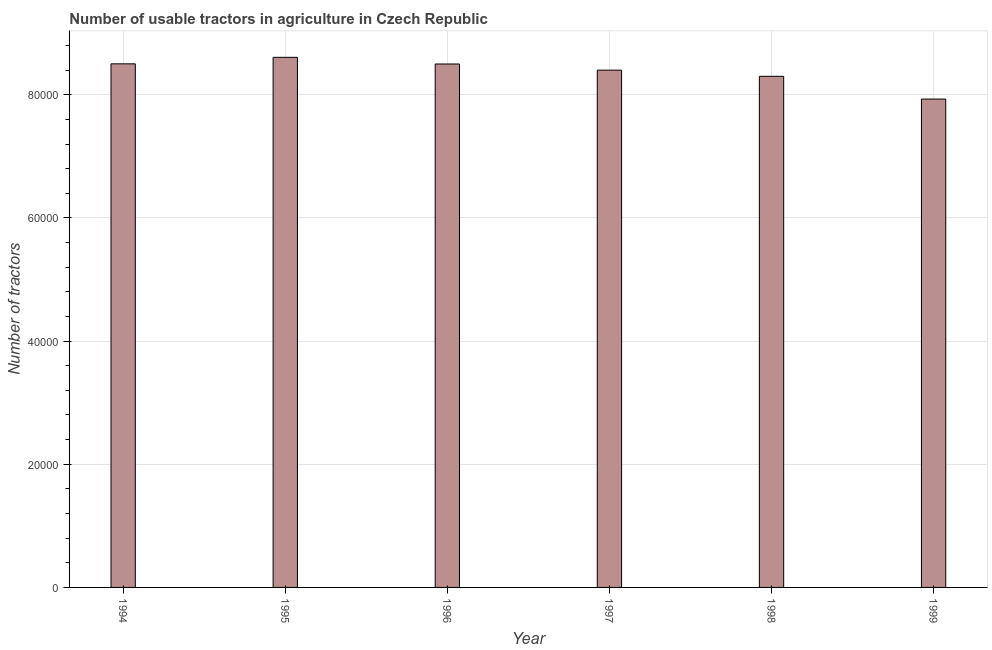Does the graph contain grids?
Keep it short and to the point. Yes. What is the title of the graph?
Offer a terse response. Number of usable tractors in agriculture in Czech Republic. What is the label or title of the Y-axis?
Your answer should be compact. Number of tractors. What is the number of tractors in 1999?
Provide a short and direct response. 7.93e+04. Across all years, what is the maximum number of tractors?
Offer a very short reply. 8.61e+04. Across all years, what is the minimum number of tractors?
Your answer should be very brief. 7.93e+04. In which year was the number of tractors minimum?
Make the answer very short. 1999. What is the sum of the number of tractors?
Your answer should be very brief. 5.02e+05. What is the difference between the number of tractors in 1994 and 1997?
Your answer should be compact. 1025. What is the average number of tractors per year?
Your answer should be compact. 8.37e+04. What is the median number of tractors?
Give a very brief answer. 8.45e+04. Do a majority of the years between 1999 and 1995 (inclusive) have number of tractors greater than 44000 ?
Give a very brief answer. Yes. What is the difference between the highest and the second highest number of tractors?
Make the answer very short. 1056. Is the sum of the number of tractors in 1995 and 1998 greater than the maximum number of tractors across all years?
Give a very brief answer. Yes. What is the difference between the highest and the lowest number of tractors?
Keep it short and to the point. 6777. Are all the bars in the graph horizontal?
Give a very brief answer. No. How many years are there in the graph?
Ensure brevity in your answer.  6. What is the difference between two consecutive major ticks on the Y-axis?
Make the answer very short. 2.00e+04. Are the values on the major ticks of Y-axis written in scientific E-notation?
Offer a very short reply. No. What is the Number of tractors of 1994?
Your answer should be compact. 8.50e+04. What is the Number of tractors in 1995?
Ensure brevity in your answer.  8.61e+04. What is the Number of tractors in 1996?
Your answer should be compact. 8.50e+04. What is the Number of tractors in 1997?
Make the answer very short. 8.40e+04. What is the Number of tractors in 1998?
Your response must be concise. 8.30e+04. What is the Number of tractors in 1999?
Your answer should be compact. 7.93e+04. What is the difference between the Number of tractors in 1994 and 1995?
Keep it short and to the point. -1056. What is the difference between the Number of tractors in 1994 and 1997?
Ensure brevity in your answer.  1025. What is the difference between the Number of tractors in 1994 and 1998?
Offer a very short reply. 2025. What is the difference between the Number of tractors in 1994 and 1999?
Give a very brief answer. 5721. What is the difference between the Number of tractors in 1995 and 1996?
Offer a very short reply. 1081. What is the difference between the Number of tractors in 1995 and 1997?
Ensure brevity in your answer.  2081. What is the difference between the Number of tractors in 1995 and 1998?
Your answer should be very brief. 3081. What is the difference between the Number of tractors in 1995 and 1999?
Offer a very short reply. 6777. What is the difference between the Number of tractors in 1996 and 1997?
Offer a terse response. 1000. What is the difference between the Number of tractors in 1996 and 1998?
Offer a terse response. 2000. What is the difference between the Number of tractors in 1996 and 1999?
Offer a very short reply. 5696. What is the difference between the Number of tractors in 1997 and 1999?
Provide a short and direct response. 4696. What is the difference between the Number of tractors in 1998 and 1999?
Ensure brevity in your answer.  3696. What is the ratio of the Number of tractors in 1994 to that in 1996?
Provide a succinct answer. 1. What is the ratio of the Number of tractors in 1994 to that in 1997?
Your answer should be compact. 1.01. What is the ratio of the Number of tractors in 1994 to that in 1998?
Your answer should be very brief. 1.02. What is the ratio of the Number of tractors in 1994 to that in 1999?
Offer a terse response. 1.07. What is the ratio of the Number of tractors in 1995 to that in 1996?
Provide a succinct answer. 1.01. What is the ratio of the Number of tractors in 1995 to that in 1997?
Give a very brief answer. 1.02. What is the ratio of the Number of tractors in 1995 to that in 1999?
Your answer should be very brief. 1.08. What is the ratio of the Number of tractors in 1996 to that in 1998?
Your response must be concise. 1.02. What is the ratio of the Number of tractors in 1996 to that in 1999?
Your answer should be compact. 1.07. What is the ratio of the Number of tractors in 1997 to that in 1999?
Provide a succinct answer. 1.06. What is the ratio of the Number of tractors in 1998 to that in 1999?
Offer a very short reply. 1.05. 